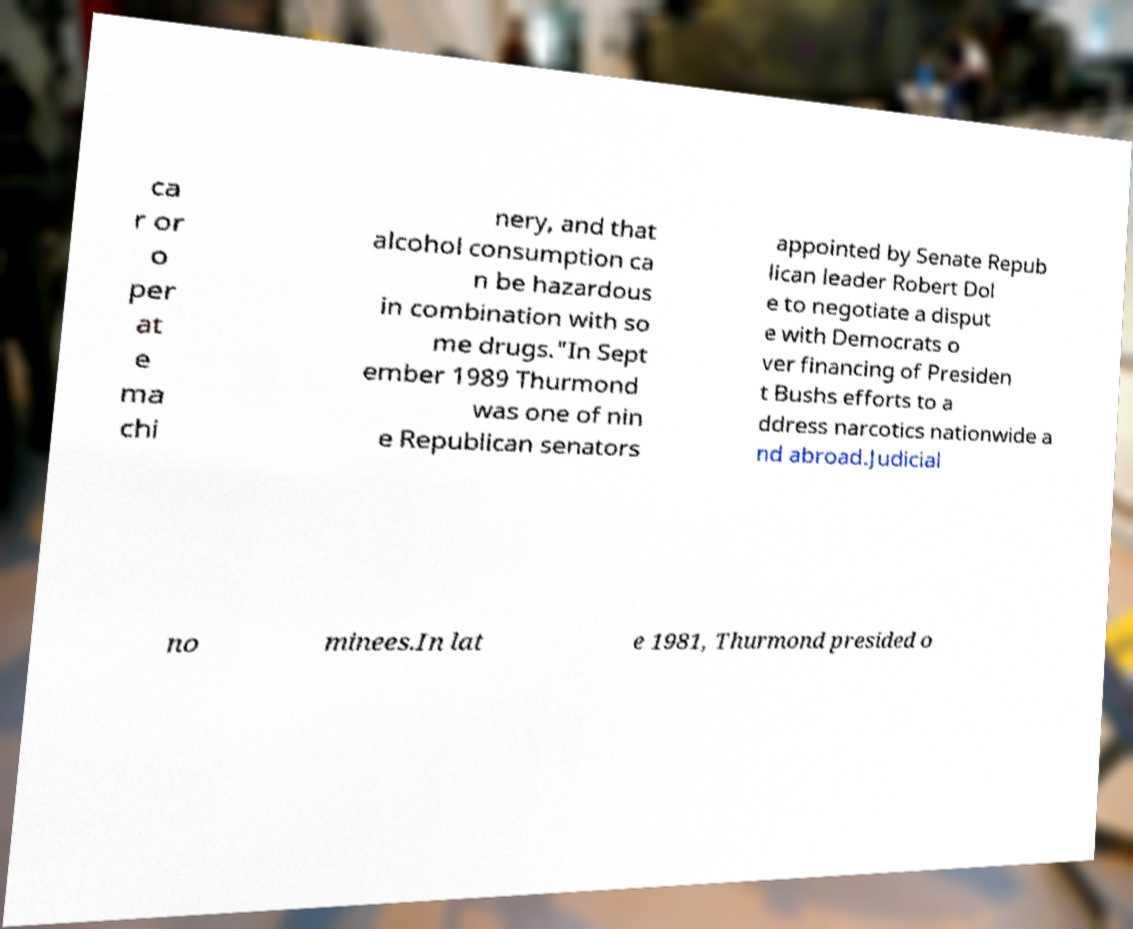What messages or text are displayed in this image? I need them in a readable, typed format. ca r or o per at e ma chi nery, and that alcohol consumption ca n be hazardous in combination with so me drugs."In Sept ember 1989 Thurmond was one of nin e Republican senators appointed by Senate Repub lican leader Robert Dol e to negotiate a disput e with Democrats o ver financing of Presiden t Bushs efforts to a ddress narcotics nationwide a nd abroad.Judicial no minees.In lat e 1981, Thurmond presided o 